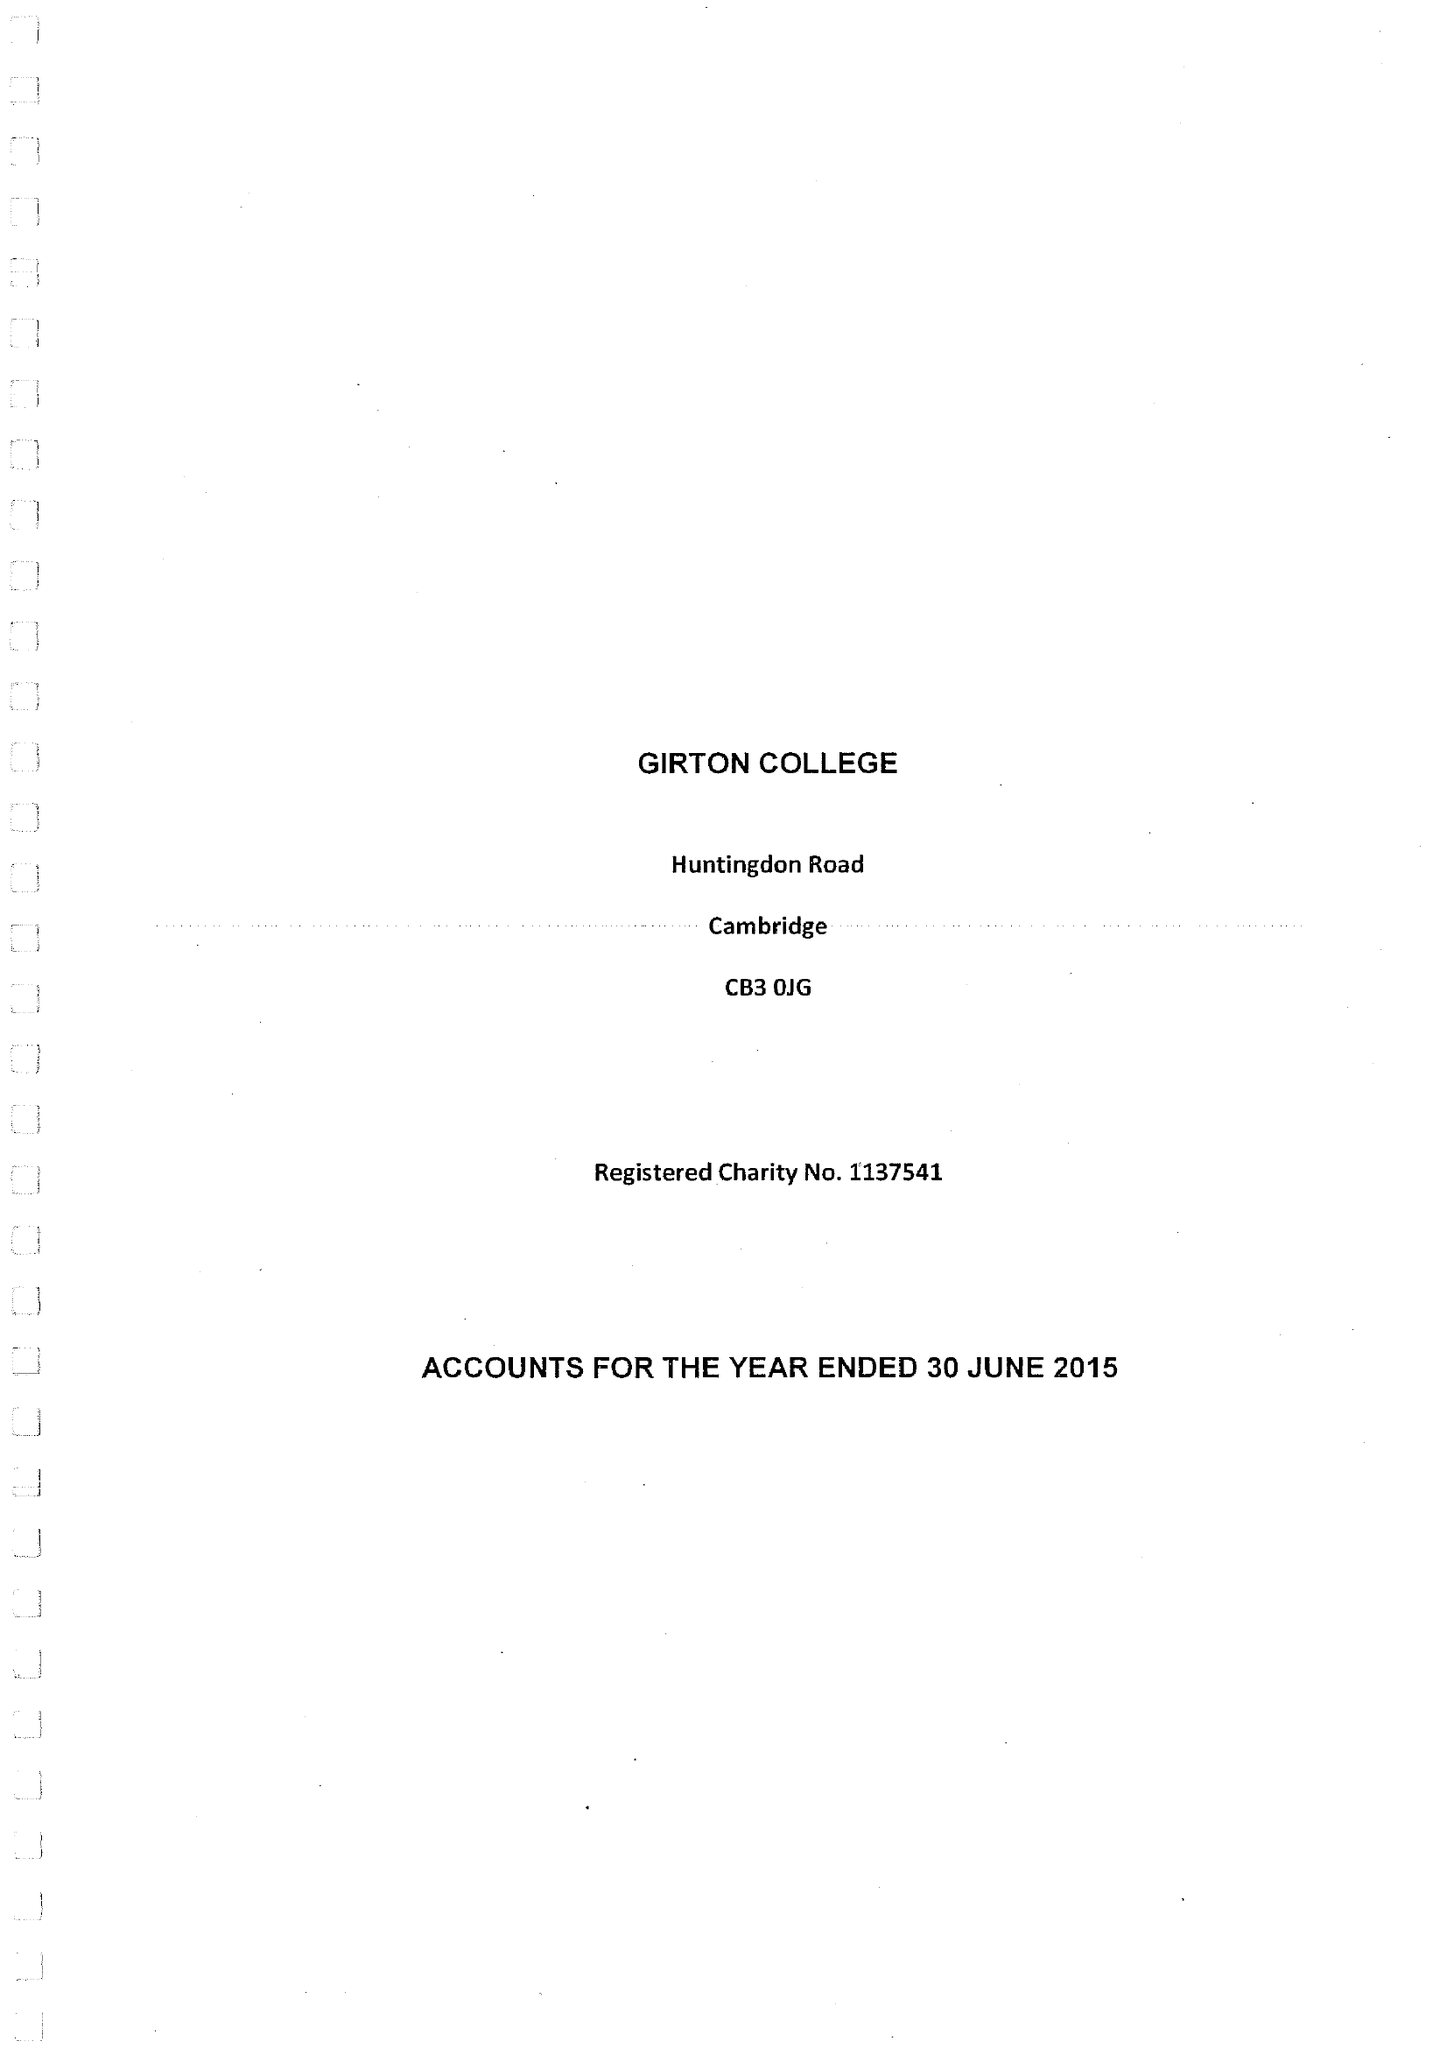What is the value for the income_annually_in_british_pounds?
Answer the question using a single word or phrase. 9184000.00 